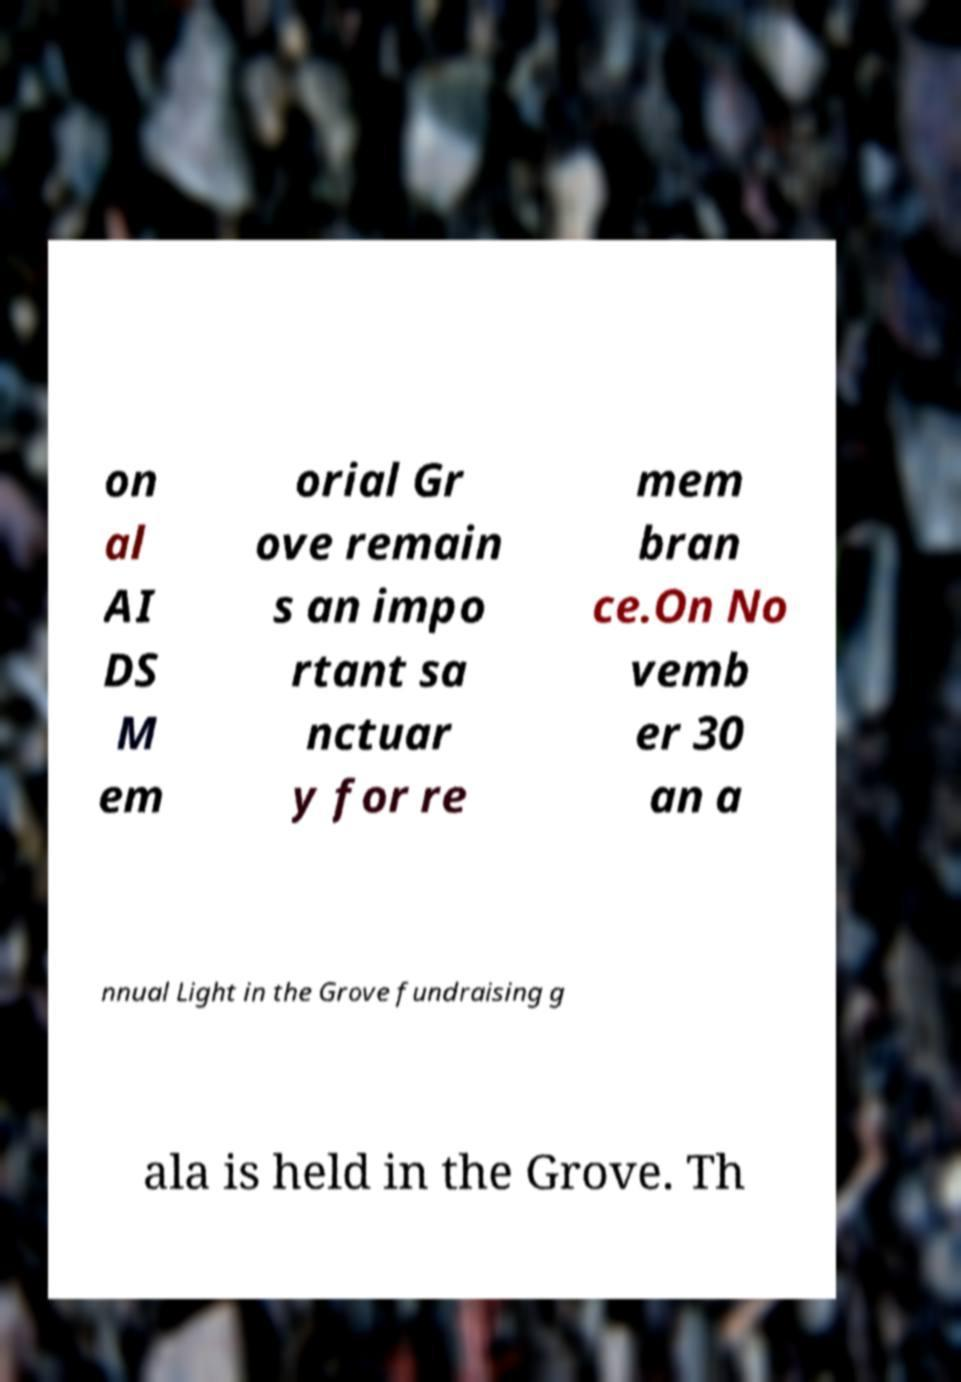I need the written content from this picture converted into text. Can you do that? on al AI DS M em orial Gr ove remain s an impo rtant sa nctuar y for re mem bran ce.On No vemb er 30 an a nnual Light in the Grove fundraising g ala is held in the Grove. Th 